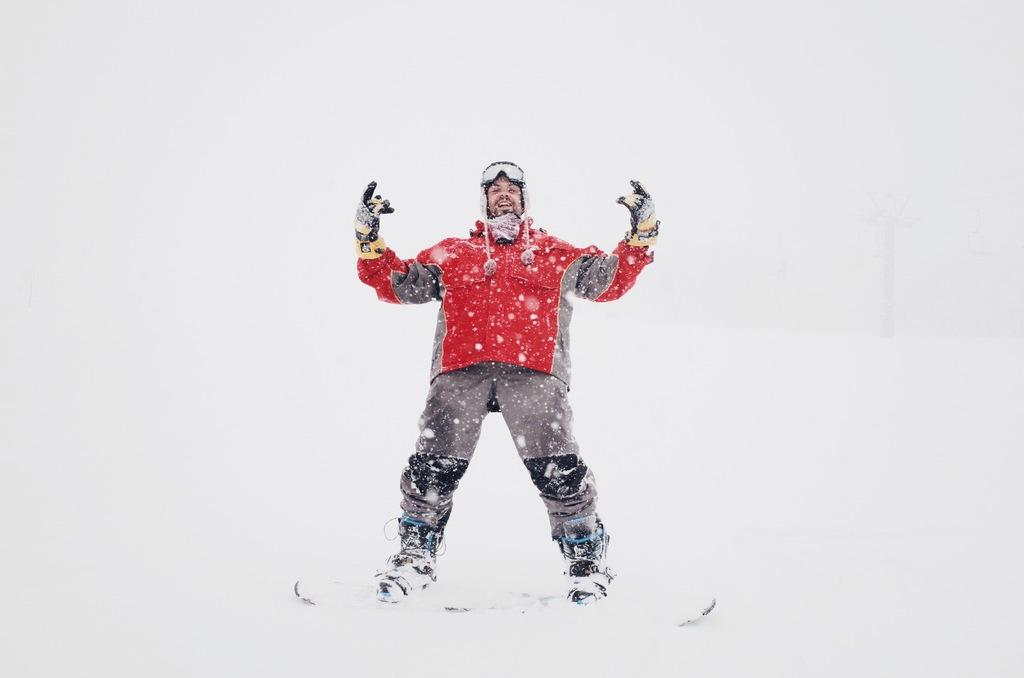What is the primary weather condition depicted in the image? There is snow in the image. Can you describe the person's attire in the image? There is a person wearing a red jacket in the image. How many eggs are being used to make the tramp in the image? There is no tramp or eggs present in the image. 